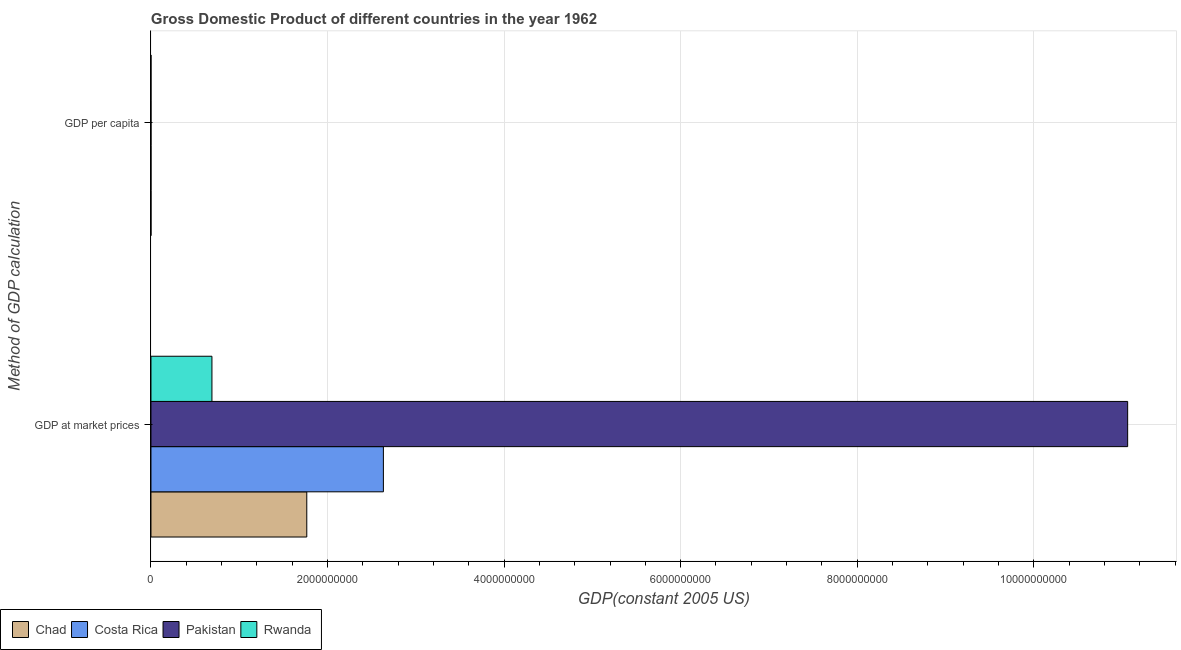How many different coloured bars are there?
Give a very brief answer. 4. Are the number of bars per tick equal to the number of legend labels?
Your answer should be compact. Yes. Are the number of bars on each tick of the Y-axis equal?
Keep it short and to the point. Yes. How many bars are there on the 1st tick from the top?
Provide a short and direct response. 4. How many bars are there on the 1st tick from the bottom?
Ensure brevity in your answer.  4. What is the label of the 2nd group of bars from the top?
Give a very brief answer. GDP at market prices. What is the gdp per capita in Chad?
Make the answer very short. 565.29. Across all countries, what is the maximum gdp per capita?
Give a very brief answer. 1837.73. Across all countries, what is the minimum gdp at market prices?
Provide a succinct answer. 6.91e+08. In which country was the gdp at market prices minimum?
Keep it short and to the point. Rwanda. What is the total gdp at market prices in the graph?
Provide a short and direct response. 1.62e+1. What is the difference between the gdp at market prices in Pakistan and that in Chad?
Provide a short and direct response. 9.30e+09. What is the difference between the gdp at market prices in Rwanda and the gdp per capita in Pakistan?
Your answer should be compact. 6.91e+08. What is the average gdp at market prices per country?
Your response must be concise. 4.04e+09. What is the difference between the gdp per capita and gdp at market prices in Chad?
Your response must be concise. -1.77e+09. In how many countries, is the gdp at market prices greater than 2800000000 US$?
Your response must be concise. 1. What is the ratio of the gdp per capita in Pakistan to that in Rwanda?
Your response must be concise. 1.04. Is the gdp per capita in Rwanda less than that in Costa Rica?
Offer a terse response. Yes. In how many countries, is the gdp at market prices greater than the average gdp at market prices taken over all countries?
Keep it short and to the point. 1. What does the 4th bar from the top in GDP at market prices represents?
Your answer should be compact. Chad. What does the 1st bar from the bottom in GDP at market prices represents?
Offer a terse response. Chad. How many bars are there?
Ensure brevity in your answer.  8. Are all the bars in the graph horizontal?
Keep it short and to the point. Yes. What is the difference between two consecutive major ticks on the X-axis?
Offer a terse response. 2.00e+09. Does the graph contain any zero values?
Your answer should be very brief. No. Does the graph contain grids?
Your response must be concise. Yes. Where does the legend appear in the graph?
Keep it short and to the point. Bottom left. What is the title of the graph?
Keep it short and to the point. Gross Domestic Product of different countries in the year 1962. Does "Libya" appear as one of the legend labels in the graph?
Keep it short and to the point. No. What is the label or title of the X-axis?
Provide a succinct answer. GDP(constant 2005 US). What is the label or title of the Y-axis?
Your answer should be compact. Method of GDP calculation. What is the GDP(constant 2005 US) of Chad in GDP at market prices?
Your answer should be compact. 1.77e+09. What is the GDP(constant 2005 US) in Costa Rica in GDP at market prices?
Provide a short and direct response. 2.63e+09. What is the GDP(constant 2005 US) in Pakistan in GDP at market prices?
Give a very brief answer. 1.11e+1. What is the GDP(constant 2005 US) in Rwanda in GDP at market prices?
Make the answer very short. 6.91e+08. What is the GDP(constant 2005 US) of Chad in GDP per capita?
Keep it short and to the point. 565.29. What is the GDP(constant 2005 US) of Costa Rica in GDP per capita?
Ensure brevity in your answer.  1837.73. What is the GDP(constant 2005 US) in Pakistan in GDP per capita?
Ensure brevity in your answer.  234.77. What is the GDP(constant 2005 US) in Rwanda in GDP per capita?
Provide a succinct answer. 226.42. Across all Method of GDP calculation, what is the maximum GDP(constant 2005 US) of Chad?
Make the answer very short. 1.77e+09. Across all Method of GDP calculation, what is the maximum GDP(constant 2005 US) of Costa Rica?
Offer a terse response. 2.63e+09. Across all Method of GDP calculation, what is the maximum GDP(constant 2005 US) in Pakistan?
Your response must be concise. 1.11e+1. Across all Method of GDP calculation, what is the maximum GDP(constant 2005 US) in Rwanda?
Your answer should be very brief. 6.91e+08. Across all Method of GDP calculation, what is the minimum GDP(constant 2005 US) of Chad?
Your response must be concise. 565.29. Across all Method of GDP calculation, what is the minimum GDP(constant 2005 US) in Costa Rica?
Provide a succinct answer. 1837.73. Across all Method of GDP calculation, what is the minimum GDP(constant 2005 US) of Pakistan?
Ensure brevity in your answer.  234.77. Across all Method of GDP calculation, what is the minimum GDP(constant 2005 US) of Rwanda?
Provide a succinct answer. 226.42. What is the total GDP(constant 2005 US) in Chad in the graph?
Make the answer very short. 1.77e+09. What is the total GDP(constant 2005 US) of Costa Rica in the graph?
Keep it short and to the point. 2.63e+09. What is the total GDP(constant 2005 US) of Pakistan in the graph?
Your answer should be very brief. 1.11e+1. What is the total GDP(constant 2005 US) of Rwanda in the graph?
Give a very brief answer. 6.91e+08. What is the difference between the GDP(constant 2005 US) in Chad in GDP at market prices and that in GDP per capita?
Provide a succinct answer. 1.77e+09. What is the difference between the GDP(constant 2005 US) of Costa Rica in GDP at market prices and that in GDP per capita?
Keep it short and to the point. 2.63e+09. What is the difference between the GDP(constant 2005 US) in Pakistan in GDP at market prices and that in GDP per capita?
Give a very brief answer. 1.11e+1. What is the difference between the GDP(constant 2005 US) of Rwanda in GDP at market prices and that in GDP per capita?
Ensure brevity in your answer.  6.91e+08. What is the difference between the GDP(constant 2005 US) in Chad in GDP at market prices and the GDP(constant 2005 US) in Costa Rica in GDP per capita?
Offer a very short reply. 1.77e+09. What is the difference between the GDP(constant 2005 US) in Chad in GDP at market prices and the GDP(constant 2005 US) in Pakistan in GDP per capita?
Offer a very short reply. 1.77e+09. What is the difference between the GDP(constant 2005 US) of Chad in GDP at market prices and the GDP(constant 2005 US) of Rwanda in GDP per capita?
Provide a short and direct response. 1.77e+09. What is the difference between the GDP(constant 2005 US) of Costa Rica in GDP at market prices and the GDP(constant 2005 US) of Pakistan in GDP per capita?
Offer a very short reply. 2.63e+09. What is the difference between the GDP(constant 2005 US) of Costa Rica in GDP at market prices and the GDP(constant 2005 US) of Rwanda in GDP per capita?
Offer a very short reply. 2.63e+09. What is the difference between the GDP(constant 2005 US) of Pakistan in GDP at market prices and the GDP(constant 2005 US) of Rwanda in GDP per capita?
Ensure brevity in your answer.  1.11e+1. What is the average GDP(constant 2005 US) of Chad per Method of GDP calculation?
Your response must be concise. 8.83e+08. What is the average GDP(constant 2005 US) in Costa Rica per Method of GDP calculation?
Offer a very short reply. 1.32e+09. What is the average GDP(constant 2005 US) of Pakistan per Method of GDP calculation?
Offer a very short reply. 5.53e+09. What is the average GDP(constant 2005 US) in Rwanda per Method of GDP calculation?
Give a very brief answer. 3.45e+08. What is the difference between the GDP(constant 2005 US) of Chad and GDP(constant 2005 US) of Costa Rica in GDP at market prices?
Your response must be concise. -8.68e+08. What is the difference between the GDP(constant 2005 US) of Chad and GDP(constant 2005 US) of Pakistan in GDP at market prices?
Your answer should be compact. -9.30e+09. What is the difference between the GDP(constant 2005 US) in Chad and GDP(constant 2005 US) in Rwanda in GDP at market prices?
Provide a succinct answer. 1.07e+09. What is the difference between the GDP(constant 2005 US) in Costa Rica and GDP(constant 2005 US) in Pakistan in GDP at market prices?
Provide a succinct answer. -8.43e+09. What is the difference between the GDP(constant 2005 US) of Costa Rica and GDP(constant 2005 US) of Rwanda in GDP at market prices?
Your answer should be very brief. 1.94e+09. What is the difference between the GDP(constant 2005 US) of Pakistan and GDP(constant 2005 US) of Rwanda in GDP at market prices?
Provide a succinct answer. 1.04e+1. What is the difference between the GDP(constant 2005 US) of Chad and GDP(constant 2005 US) of Costa Rica in GDP per capita?
Your answer should be very brief. -1272.44. What is the difference between the GDP(constant 2005 US) of Chad and GDP(constant 2005 US) of Pakistan in GDP per capita?
Offer a terse response. 330.52. What is the difference between the GDP(constant 2005 US) in Chad and GDP(constant 2005 US) in Rwanda in GDP per capita?
Offer a very short reply. 338.87. What is the difference between the GDP(constant 2005 US) of Costa Rica and GDP(constant 2005 US) of Pakistan in GDP per capita?
Keep it short and to the point. 1602.96. What is the difference between the GDP(constant 2005 US) of Costa Rica and GDP(constant 2005 US) of Rwanda in GDP per capita?
Give a very brief answer. 1611.31. What is the difference between the GDP(constant 2005 US) in Pakistan and GDP(constant 2005 US) in Rwanda in GDP per capita?
Your answer should be compact. 8.35. What is the ratio of the GDP(constant 2005 US) of Chad in GDP at market prices to that in GDP per capita?
Your response must be concise. 3.12e+06. What is the ratio of the GDP(constant 2005 US) in Costa Rica in GDP at market prices to that in GDP per capita?
Your response must be concise. 1.43e+06. What is the ratio of the GDP(constant 2005 US) in Pakistan in GDP at market prices to that in GDP per capita?
Offer a terse response. 4.71e+07. What is the ratio of the GDP(constant 2005 US) of Rwanda in GDP at market prices to that in GDP per capita?
Your answer should be compact. 3.05e+06. What is the difference between the highest and the second highest GDP(constant 2005 US) of Chad?
Offer a very short reply. 1.77e+09. What is the difference between the highest and the second highest GDP(constant 2005 US) of Costa Rica?
Your response must be concise. 2.63e+09. What is the difference between the highest and the second highest GDP(constant 2005 US) of Pakistan?
Your answer should be compact. 1.11e+1. What is the difference between the highest and the second highest GDP(constant 2005 US) of Rwanda?
Keep it short and to the point. 6.91e+08. What is the difference between the highest and the lowest GDP(constant 2005 US) in Chad?
Ensure brevity in your answer.  1.77e+09. What is the difference between the highest and the lowest GDP(constant 2005 US) of Costa Rica?
Offer a very short reply. 2.63e+09. What is the difference between the highest and the lowest GDP(constant 2005 US) of Pakistan?
Offer a terse response. 1.11e+1. What is the difference between the highest and the lowest GDP(constant 2005 US) of Rwanda?
Your answer should be very brief. 6.91e+08. 